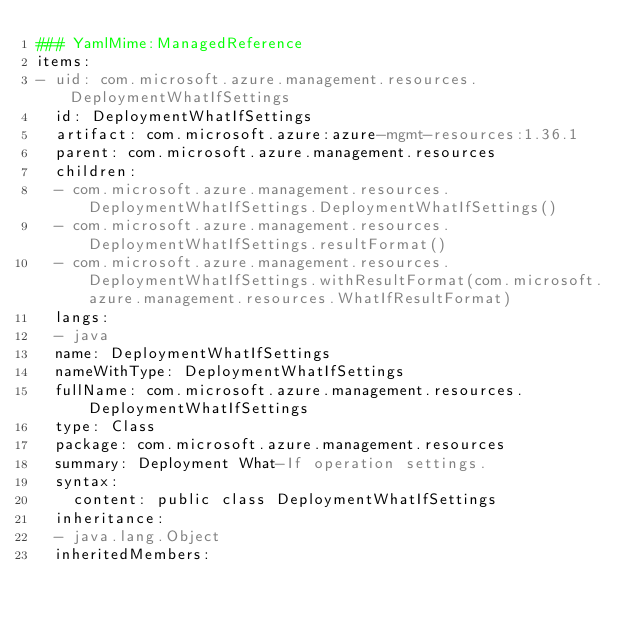<code> <loc_0><loc_0><loc_500><loc_500><_YAML_>### YamlMime:ManagedReference
items:
- uid: com.microsoft.azure.management.resources.DeploymentWhatIfSettings
  id: DeploymentWhatIfSettings
  artifact: com.microsoft.azure:azure-mgmt-resources:1.36.1
  parent: com.microsoft.azure.management.resources
  children:
  - com.microsoft.azure.management.resources.DeploymentWhatIfSettings.DeploymentWhatIfSettings()
  - com.microsoft.azure.management.resources.DeploymentWhatIfSettings.resultFormat()
  - com.microsoft.azure.management.resources.DeploymentWhatIfSettings.withResultFormat(com.microsoft.azure.management.resources.WhatIfResultFormat)
  langs:
  - java
  name: DeploymentWhatIfSettings
  nameWithType: DeploymentWhatIfSettings
  fullName: com.microsoft.azure.management.resources.DeploymentWhatIfSettings
  type: Class
  package: com.microsoft.azure.management.resources
  summary: Deployment What-If operation settings.
  syntax:
    content: public class DeploymentWhatIfSettings
  inheritance:
  - java.lang.Object
  inheritedMembers:</code> 